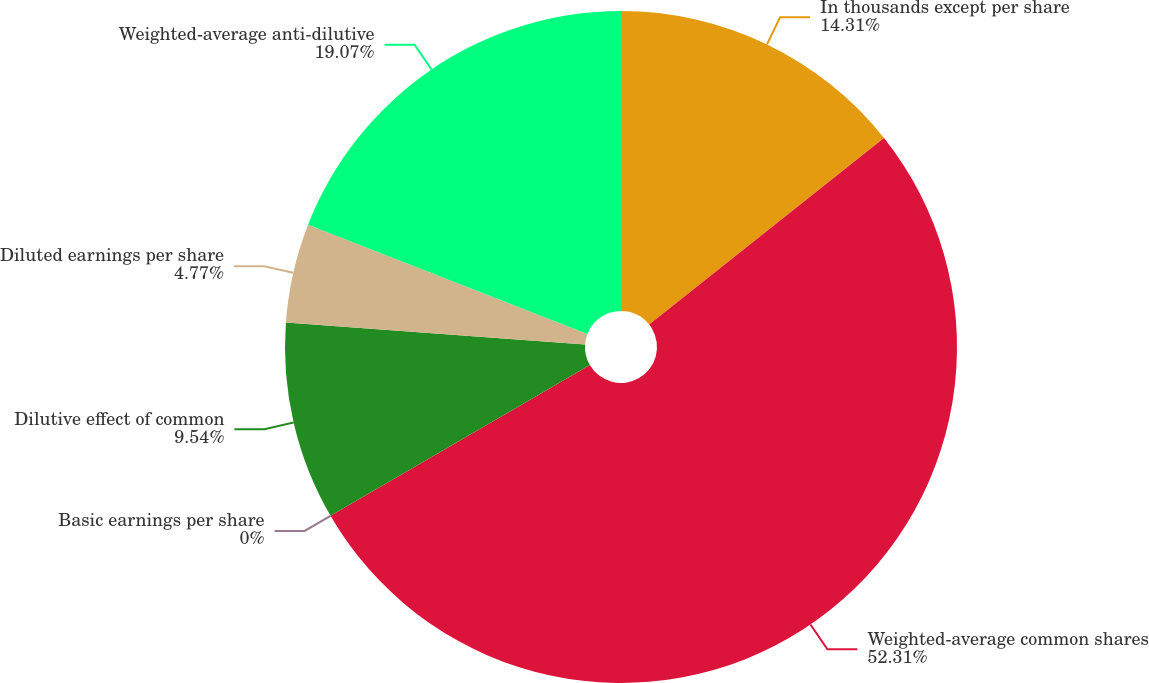Convert chart. <chart><loc_0><loc_0><loc_500><loc_500><pie_chart><fcel>In thousands except per share<fcel>Weighted-average common shares<fcel>Basic earnings per share<fcel>Dilutive effect of common<fcel>Diluted earnings per share<fcel>Weighted-average anti-dilutive<nl><fcel>14.31%<fcel>52.31%<fcel>0.0%<fcel>9.54%<fcel>4.77%<fcel>19.07%<nl></chart> 